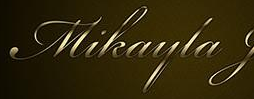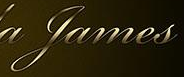What words can you see in these images in sequence, separated by a semicolon? Mikayla; James 